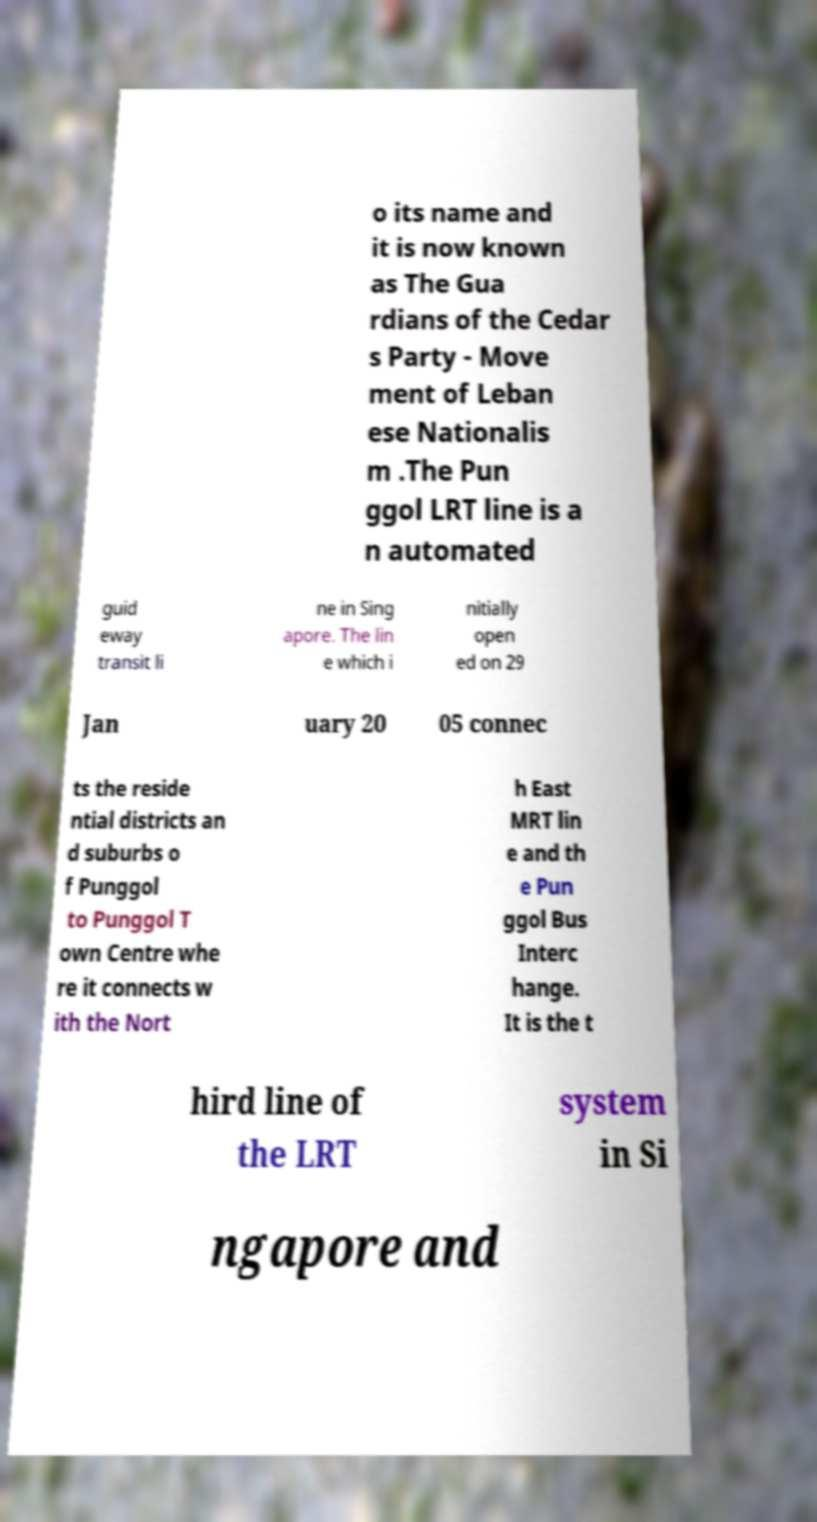For documentation purposes, I need the text within this image transcribed. Could you provide that? o its name and it is now known as The Gua rdians of the Cedar s Party - Move ment of Leban ese Nationalis m .The Pun ggol LRT line is a n automated guid eway transit li ne in Sing apore. The lin e which i nitially open ed on 29 Jan uary 20 05 connec ts the reside ntial districts an d suburbs o f Punggol to Punggol T own Centre whe re it connects w ith the Nort h East MRT lin e and th e Pun ggol Bus Interc hange. It is the t hird line of the LRT system in Si ngapore and 